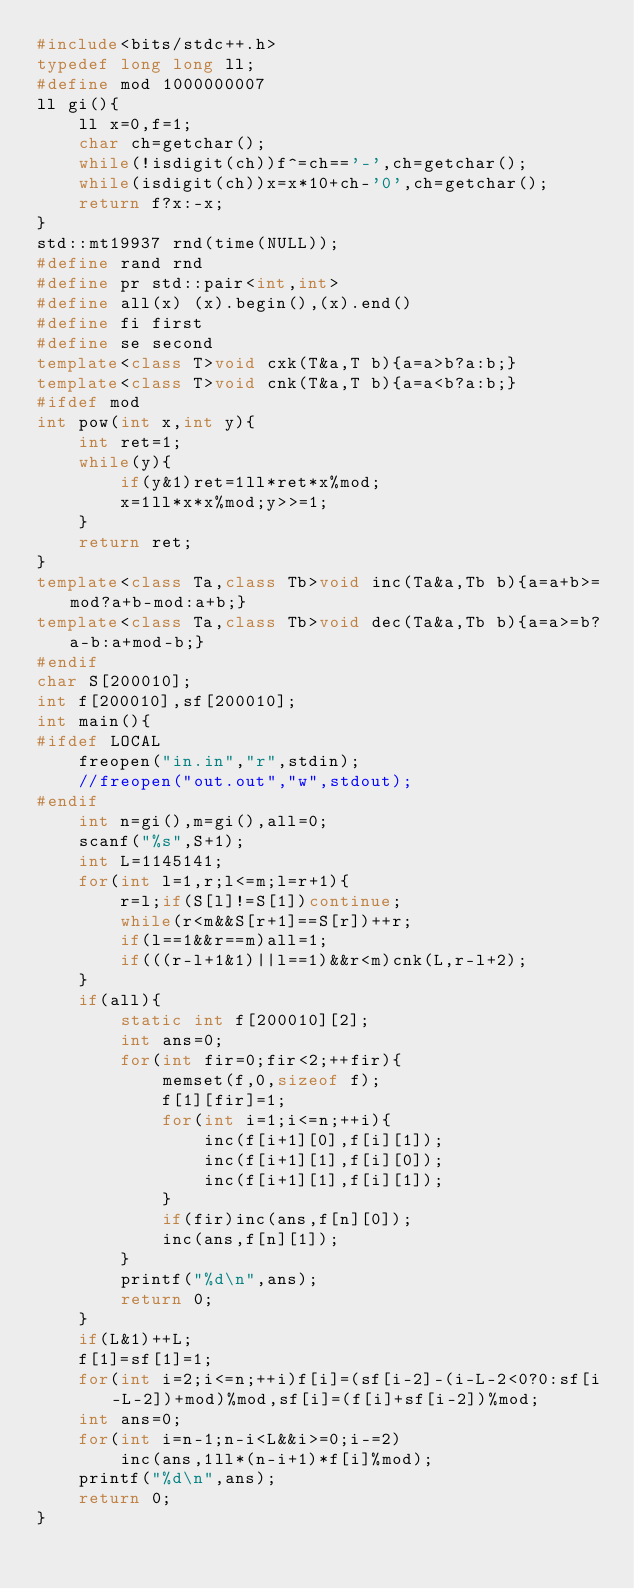<code> <loc_0><loc_0><loc_500><loc_500><_C++_>#include<bits/stdc++.h>
typedef long long ll;
#define mod 1000000007
ll gi(){
	ll x=0,f=1;
	char ch=getchar();
	while(!isdigit(ch))f^=ch=='-',ch=getchar();
	while(isdigit(ch))x=x*10+ch-'0',ch=getchar();
	return f?x:-x;
}
std::mt19937 rnd(time(NULL));
#define rand rnd
#define pr std::pair<int,int>
#define all(x) (x).begin(),(x).end()
#define fi first
#define se second
template<class T>void cxk(T&a,T b){a=a>b?a:b;}
template<class T>void cnk(T&a,T b){a=a<b?a:b;}
#ifdef mod
int pow(int x,int y){
	int ret=1;
	while(y){
		if(y&1)ret=1ll*ret*x%mod;
		x=1ll*x*x%mod;y>>=1;
	}
	return ret;
}
template<class Ta,class Tb>void inc(Ta&a,Tb b){a=a+b>=mod?a+b-mod:a+b;}
template<class Ta,class Tb>void dec(Ta&a,Tb b){a=a>=b?a-b:a+mod-b;}
#endif
char S[200010];
int f[200010],sf[200010];
int main(){
#ifdef LOCAL
	freopen("in.in","r",stdin);
	//freopen("out.out","w",stdout);
#endif
	int n=gi(),m=gi(),all=0;
	scanf("%s",S+1);
	int L=1145141;
	for(int l=1,r;l<=m;l=r+1){
		r=l;if(S[l]!=S[1])continue;
		while(r<m&&S[r+1]==S[r])++r;
		if(l==1&&r==m)all=1;
		if(((r-l+1&1)||l==1)&&r<m)cnk(L,r-l+2);
	}
	if(all){
		static int f[200010][2];
		int ans=0;
		for(int fir=0;fir<2;++fir){
			memset(f,0,sizeof f);
			f[1][fir]=1;
			for(int i=1;i<=n;++i){
				inc(f[i+1][0],f[i][1]);
				inc(f[i+1][1],f[i][0]);
				inc(f[i+1][1],f[i][1]);
			}
			if(fir)inc(ans,f[n][0]);
			inc(ans,f[n][1]);
		}
		printf("%d\n",ans);
		return 0;
	}
	if(L&1)++L;
	f[1]=sf[1]=1;
	for(int i=2;i<=n;++i)f[i]=(sf[i-2]-(i-L-2<0?0:sf[i-L-2])+mod)%mod,sf[i]=(f[i]+sf[i-2])%mod;
	int ans=0;
	for(int i=n-1;n-i<L&&i>=0;i-=2)
		inc(ans,1ll*(n-i+1)*f[i]%mod);
	printf("%d\n",ans);
	return 0;
}
</code> 